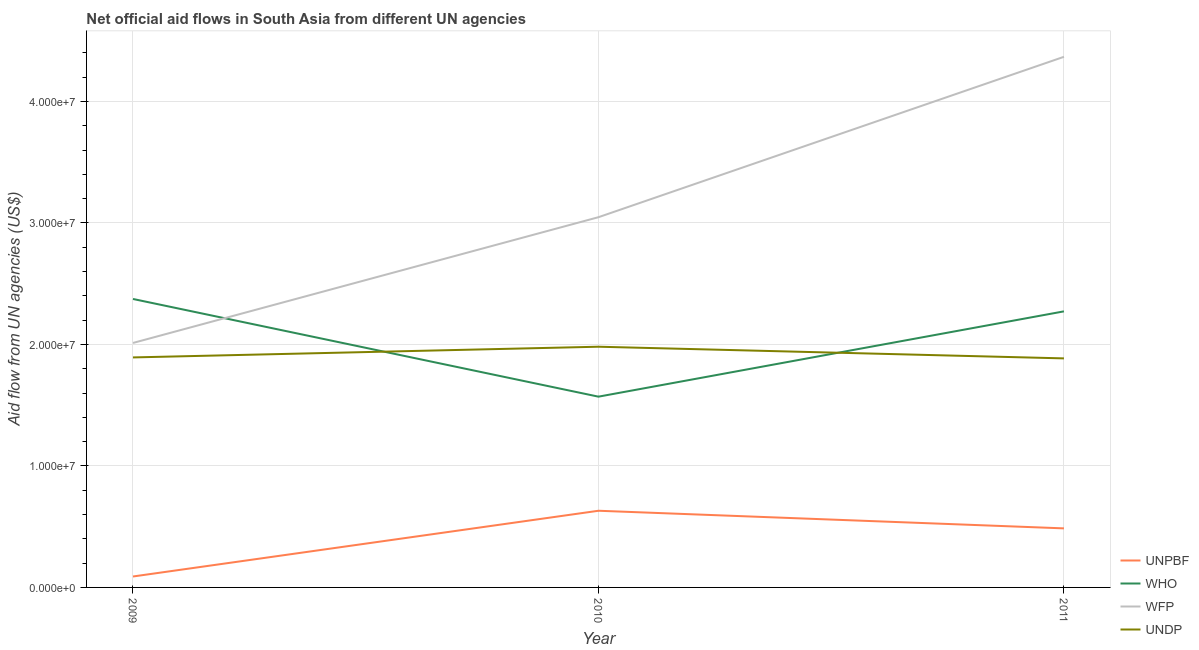What is the amount of aid given by wfp in 2009?
Offer a very short reply. 2.01e+07. Across all years, what is the maximum amount of aid given by undp?
Provide a short and direct response. 1.98e+07. Across all years, what is the minimum amount of aid given by who?
Make the answer very short. 1.57e+07. In which year was the amount of aid given by unpbf maximum?
Keep it short and to the point. 2010. What is the total amount of aid given by wfp in the graph?
Ensure brevity in your answer.  9.43e+07. What is the difference between the amount of aid given by wfp in 2009 and that in 2010?
Provide a succinct answer. -1.04e+07. What is the difference between the amount of aid given by undp in 2011 and the amount of aid given by who in 2009?
Provide a short and direct response. -4.89e+06. What is the average amount of aid given by wfp per year?
Ensure brevity in your answer.  3.14e+07. In the year 2010, what is the difference between the amount of aid given by who and amount of aid given by wfp?
Provide a short and direct response. -1.48e+07. In how many years, is the amount of aid given by unpbf greater than 40000000 US$?
Your answer should be compact. 0. What is the ratio of the amount of aid given by wfp in 2009 to that in 2011?
Provide a short and direct response. 0.46. Is the amount of aid given by wfp in 2009 less than that in 2011?
Offer a very short reply. Yes. What is the difference between the highest and the second highest amount of aid given by unpbf?
Your response must be concise. 1.45e+06. What is the difference between the highest and the lowest amount of aid given by who?
Your response must be concise. 8.04e+06. Is it the case that in every year, the sum of the amount of aid given by who and amount of aid given by undp is greater than the sum of amount of aid given by unpbf and amount of aid given by wfp?
Provide a short and direct response. No. Is it the case that in every year, the sum of the amount of aid given by unpbf and amount of aid given by who is greater than the amount of aid given by wfp?
Give a very brief answer. No. Does the amount of aid given by undp monotonically increase over the years?
Your response must be concise. No. Is the amount of aid given by unpbf strictly greater than the amount of aid given by undp over the years?
Your answer should be very brief. No. How many lines are there?
Provide a short and direct response. 4. What is the difference between two consecutive major ticks on the Y-axis?
Your answer should be very brief. 1.00e+07. Does the graph contain grids?
Keep it short and to the point. Yes. Where does the legend appear in the graph?
Give a very brief answer. Bottom right. How many legend labels are there?
Ensure brevity in your answer.  4. What is the title of the graph?
Your answer should be compact. Net official aid flows in South Asia from different UN agencies. Does "Macroeconomic management" appear as one of the legend labels in the graph?
Keep it short and to the point. No. What is the label or title of the Y-axis?
Give a very brief answer. Aid flow from UN agencies (US$). What is the Aid flow from UN agencies (US$) in WHO in 2009?
Keep it short and to the point. 2.37e+07. What is the Aid flow from UN agencies (US$) of WFP in 2009?
Make the answer very short. 2.01e+07. What is the Aid flow from UN agencies (US$) of UNDP in 2009?
Make the answer very short. 1.89e+07. What is the Aid flow from UN agencies (US$) in UNPBF in 2010?
Offer a very short reply. 6.31e+06. What is the Aid flow from UN agencies (US$) in WHO in 2010?
Provide a short and direct response. 1.57e+07. What is the Aid flow from UN agencies (US$) of WFP in 2010?
Provide a short and direct response. 3.05e+07. What is the Aid flow from UN agencies (US$) of UNDP in 2010?
Your answer should be very brief. 1.98e+07. What is the Aid flow from UN agencies (US$) in UNPBF in 2011?
Your answer should be very brief. 4.86e+06. What is the Aid flow from UN agencies (US$) in WHO in 2011?
Provide a succinct answer. 2.27e+07. What is the Aid flow from UN agencies (US$) in WFP in 2011?
Make the answer very short. 4.37e+07. What is the Aid flow from UN agencies (US$) of UNDP in 2011?
Your response must be concise. 1.88e+07. Across all years, what is the maximum Aid flow from UN agencies (US$) in UNPBF?
Your answer should be very brief. 6.31e+06. Across all years, what is the maximum Aid flow from UN agencies (US$) in WHO?
Provide a succinct answer. 2.37e+07. Across all years, what is the maximum Aid flow from UN agencies (US$) of WFP?
Ensure brevity in your answer.  4.37e+07. Across all years, what is the maximum Aid flow from UN agencies (US$) of UNDP?
Ensure brevity in your answer.  1.98e+07. Across all years, what is the minimum Aid flow from UN agencies (US$) in WHO?
Give a very brief answer. 1.57e+07. Across all years, what is the minimum Aid flow from UN agencies (US$) in WFP?
Offer a terse response. 2.01e+07. Across all years, what is the minimum Aid flow from UN agencies (US$) in UNDP?
Your response must be concise. 1.88e+07. What is the total Aid flow from UN agencies (US$) in UNPBF in the graph?
Your answer should be very brief. 1.21e+07. What is the total Aid flow from UN agencies (US$) in WHO in the graph?
Keep it short and to the point. 6.22e+07. What is the total Aid flow from UN agencies (US$) in WFP in the graph?
Make the answer very short. 9.43e+07. What is the total Aid flow from UN agencies (US$) in UNDP in the graph?
Offer a very short reply. 5.76e+07. What is the difference between the Aid flow from UN agencies (US$) of UNPBF in 2009 and that in 2010?
Your answer should be very brief. -5.41e+06. What is the difference between the Aid flow from UN agencies (US$) in WHO in 2009 and that in 2010?
Offer a very short reply. 8.04e+06. What is the difference between the Aid flow from UN agencies (US$) of WFP in 2009 and that in 2010?
Provide a succinct answer. -1.04e+07. What is the difference between the Aid flow from UN agencies (US$) in UNDP in 2009 and that in 2010?
Your response must be concise. -8.80e+05. What is the difference between the Aid flow from UN agencies (US$) of UNPBF in 2009 and that in 2011?
Ensure brevity in your answer.  -3.96e+06. What is the difference between the Aid flow from UN agencies (US$) in WHO in 2009 and that in 2011?
Your answer should be compact. 1.02e+06. What is the difference between the Aid flow from UN agencies (US$) in WFP in 2009 and that in 2011?
Your response must be concise. -2.36e+07. What is the difference between the Aid flow from UN agencies (US$) in UNPBF in 2010 and that in 2011?
Make the answer very short. 1.45e+06. What is the difference between the Aid flow from UN agencies (US$) of WHO in 2010 and that in 2011?
Give a very brief answer. -7.02e+06. What is the difference between the Aid flow from UN agencies (US$) of WFP in 2010 and that in 2011?
Your answer should be very brief. -1.32e+07. What is the difference between the Aid flow from UN agencies (US$) in UNDP in 2010 and that in 2011?
Offer a terse response. 9.60e+05. What is the difference between the Aid flow from UN agencies (US$) of UNPBF in 2009 and the Aid flow from UN agencies (US$) of WHO in 2010?
Make the answer very short. -1.48e+07. What is the difference between the Aid flow from UN agencies (US$) of UNPBF in 2009 and the Aid flow from UN agencies (US$) of WFP in 2010?
Ensure brevity in your answer.  -2.96e+07. What is the difference between the Aid flow from UN agencies (US$) of UNPBF in 2009 and the Aid flow from UN agencies (US$) of UNDP in 2010?
Make the answer very short. -1.89e+07. What is the difference between the Aid flow from UN agencies (US$) of WHO in 2009 and the Aid flow from UN agencies (US$) of WFP in 2010?
Provide a succinct answer. -6.73e+06. What is the difference between the Aid flow from UN agencies (US$) of WHO in 2009 and the Aid flow from UN agencies (US$) of UNDP in 2010?
Your answer should be very brief. 3.93e+06. What is the difference between the Aid flow from UN agencies (US$) in UNPBF in 2009 and the Aid flow from UN agencies (US$) in WHO in 2011?
Your answer should be very brief. -2.18e+07. What is the difference between the Aid flow from UN agencies (US$) of UNPBF in 2009 and the Aid flow from UN agencies (US$) of WFP in 2011?
Ensure brevity in your answer.  -4.28e+07. What is the difference between the Aid flow from UN agencies (US$) of UNPBF in 2009 and the Aid flow from UN agencies (US$) of UNDP in 2011?
Your response must be concise. -1.80e+07. What is the difference between the Aid flow from UN agencies (US$) of WHO in 2009 and the Aid flow from UN agencies (US$) of WFP in 2011?
Your response must be concise. -1.99e+07. What is the difference between the Aid flow from UN agencies (US$) of WHO in 2009 and the Aid flow from UN agencies (US$) of UNDP in 2011?
Provide a short and direct response. 4.89e+06. What is the difference between the Aid flow from UN agencies (US$) in WFP in 2009 and the Aid flow from UN agencies (US$) in UNDP in 2011?
Provide a succinct answer. 1.27e+06. What is the difference between the Aid flow from UN agencies (US$) in UNPBF in 2010 and the Aid flow from UN agencies (US$) in WHO in 2011?
Offer a very short reply. -1.64e+07. What is the difference between the Aid flow from UN agencies (US$) in UNPBF in 2010 and the Aid flow from UN agencies (US$) in WFP in 2011?
Your response must be concise. -3.74e+07. What is the difference between the Aid flow from UN agencies (US$) of UNPBF in 2010 and the Aid flow from UN agencies (US$) of UNDP in 2011?
Offer a terse response. -1.25e+07. What is the difference between the Aid flow from UN agencies (US$) in WHO in 2010 and the Aid flow from UN agencies (US$) in WFP in 2011?
Offer a very short reply. -2.80e+07. What is the difference between the Aid flow from UN agencies (US$) in WHO in 2010 and the Aid flow from UN agencies (US$) in UNDP in 2011?
Offer a terse response. -3.15e+06. What is the difference between the Aid flow from UN agencies (US$) in WFP in 2010 and the Aid flow from UN agencies (US$) in UNDP in 2011?
Ensure brevity in your answer.  1.16e+07. What is the average Aid flow from UN agencies (US$) in UNPBF per year?
Offer a terse response. 4.02e+06. What is the average Aid flow from UN agencies (US$) of WHO per year?
Offer a terse response. 2.07e+07. What is the average Aid flow from UN agencies (US$) of WFP per year?
Ensure brevity in your answer.  3.14e+07. What is the average Aid flow from UN agencies (US$) in UNDP per year?
Give a very brief answer. 1.92e+07. In the year 2009, what is the difference between the Aid flow from UN agencies (US$) of UNPBF and Aid flow from UN agencies (US$) of WHO?
Provide a succinct answer. -2.28e+07. In the year 2009, what is the difference between the Aid flow from UN agencies (US$) in UNPBF and Aid flow from UN agencies (US$) in WFP?
Ensure brevity in your answer.  -1.92e+07. In the year 2009, what is the difference between the Aid flow from UN agencies (US$) of UNPBF and Aid flow from UN agencies (US$) of UNDP?
Ensure brevity in your answer.  -1.80e+07. In the year 2009, what is the difference between the Aid flow from UN agencies (US$) of WHO and Aid flow from UN agencies (US$) of WFP?
Make the answer very short. 3.62e+06. In the year 2009, what is the difference between the Aid flow from UN agencies (US$) of WHO and Aid flow from UN agencies (US$) of UNDP?
Provide a short and direct response. 4.81e+06. In the year 2009, what is the difference between the Aid flow from UN agencies (US$) in WFP and Aid flow from UN agencies (US$) in UNDP?
Offer a terse response. 1.19e+06. In the year 2010, what is the difference between the Aid flow from UN agencies (US$) in UNPBF and Aid flow from UN agencies (US$) in WHO?
Offer a very short reply. -9.39e+06. In the year 2010, what is the difference between the Aid flow from UN agencies (US$) of UNPBF and Aid flow from UN agencies (US$) of WFP?
Offer a very short reply. -2.42e+07. In the year 2010, what is the difference between the Aid flow from UN agencies (US$) of UNPBF and Aid flow from UN agencies (US$) of UNDP?
Provide a short and direct response. -1.35e+07. In the year 2010, what is the difference between the Aid flow from UN agencies (US$) in WHO and Aid flow from UN agencies (US$) in WFP?
Provide a short and direct response. -1.48e+07. In the year 2010, what is the difference between the Aid flow from UN agencies (US$) in WHO and Aid flow from UN agencies (US$) in UNDP?
Keep it short and to the point. -4.11e+06. In the year 2010, what is the difference between the Aid flow from UN agencies (US$) in WFP and Aid flow from UN agencies (US$) in UNDP?
Give a very brief answer. 1.07e+07. In the year 2011, what is the difference between the Aid flow from UN agencies (US$) in UNPBF and Aid flow from UN agencies (US$) in WHO?
Your response must be concise. -1.79e+07. In the year 2011, what is the difference between the Aid flow from UN agencies (US$) of UNPBF and Aid flow from UN agencies (US$) of WFP?
Offer a very short reply. -3.88e+07. In the year 2011, what is the difference between the Aid flow from UN agencies (US$) of UNPBF and Aid flow from UN agencies (US$) of UNDP?
Provide a succinct answer. -1.40e+07. In the year 2011, what is the difference between the Aid flow from UN agencies (US$) in WHO and Aid flow from UN agencies (US$) in WFP?
Ensure brevity in your answer.  -2.10e+07. In the year 2011, what is the difference between the Aid flow from UN agencies (US$) of WHO and Aid flow from UN agencies (US$) of UNDP?
Your response must be concise. 3.87e+06. In the year 2011, what is the difference between the Aid flow from UN agencies (US$) in WFP and Aid flow from UN agencies (US$) in UNDP?
Your answer should be very brief. 2.48e+07. What is the ratio of the Aid flow from UN agencies (US$) of UNPBF in 2009 to that in 2010?
Your answer should be compact. 0.14. What is the ratio of the Aid flow from UN agencies (US$) in WHO in 2009 to that in 2010?
Provide a short and direct response. 1.51. What is the ratio of the Aid flow from UN agencies (US$) in WFP in 2009 to that in 2010?
Keep it short and to the point. 0.66. What is the ratio of the Aid flow from UN agencies (US$) of UNDP in 2009 to that in 2010?
Give a very brief answer. 0.96. What is the ratio of the Aid flow from UN agencies (US$) of UNPBF in 2009 to that in 2011?
Offer a very short reply. 0.19. What is the ratio of the Aid flow from UN agencies (US$) of WHO in 2009 to that in 2011?
Give a very brief answer. 1.04. What is the ratio of the Aid flow from UN agencies (US$) in WFP in 2009 to that in 2011?
Give a very brief answer. 0.46. What is the ratio of the Aid flow from UN agencies (US$) in UNPBF in 2010 to that in 2011?
Offer a very short reply. 1.3. What is the ratio of the Aid flow from UN agencies (US$) in WHO in 2010 to that in 2011?
Offer a very short reply. 0.69. What is the ratio of the Aid flow from UN agencies (US$) in WFP in 2010 to that in 2011?
Provide a short and direct response. 0.7. What is the ratio of the Aid flow from UN agencies (US$) of UNDP in 2010 to that in 2011?
Offer a very short reply. 1.05. What is the difference between the highest and the second highest Aid flow from UN agencies (US$) of UNPBF?
Your answer should be compact. 1.45e+06. What is the difference between the highest and the second highest Aid flow from UN agencies (US$) in WHO?
Offer a very short reply. 1.02e+06. What is the difference between the highest and the second highest Aid flow from UN agencies (US$) in WFP?
Provide a short and direct response. 1.32e+07. What is the difference between the highest and the second highest Aid flow from UN agencies (US$) of UNDP?
Offer a terse response. 8.80e+05. What is the difference between the highest and the lowest Aid flow from UN agencies (US$) in UNPBF?
Your response must be concise. 5.41e+06. What is the difference between the highest and the lowest Aid flow from UN agencies (US$) in WHO?
Ensure brevity in your answer.  8.04e+06. What is the difference between the highest and the lowest Aid flow from UN agencies (US$) in WFP?
Your answer should be compact. 2.36e+07. What is the difference between the highest and the lowest Aid flow from UN agencies (US$) of UNDP?
Your answer should be very brief. 9.60e+05. 